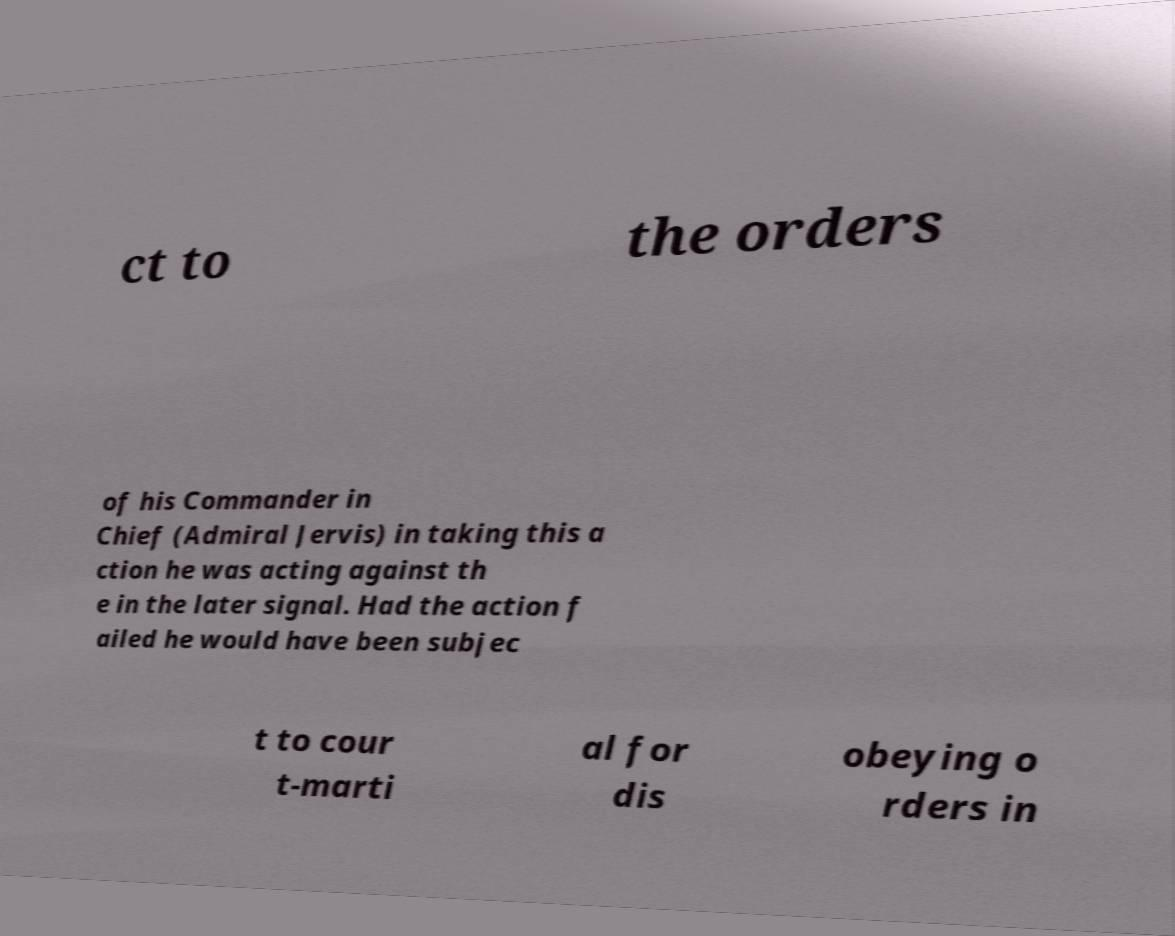What messages or text are displayed in this image? I need them in a readable, typed format. ct to the orders of his Commander in Chief (Admiral Jervis) in taking this a ction he was acting against th e in the later signal. Had the action f ailed he would have been subjec t to cour t-marti al for dis obeying o rders in 